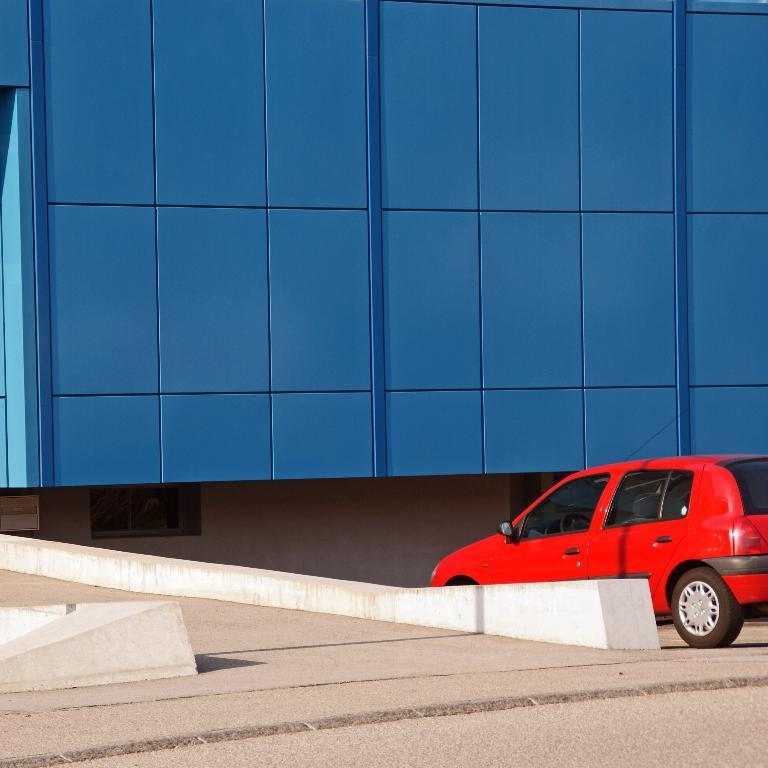What type of vehicle is in the image? There is a red car in the image. What is the car doing in the image? The car is moving on the right side of the road. What structure can be seen in the image? There is a building in the image, and it appears to be blue. What is the setting of the image? The image features a road on the left side. Can you see any branches growing from the car in the image? There are no branches visible in the image; it features a red car moving on the right side of the road. 